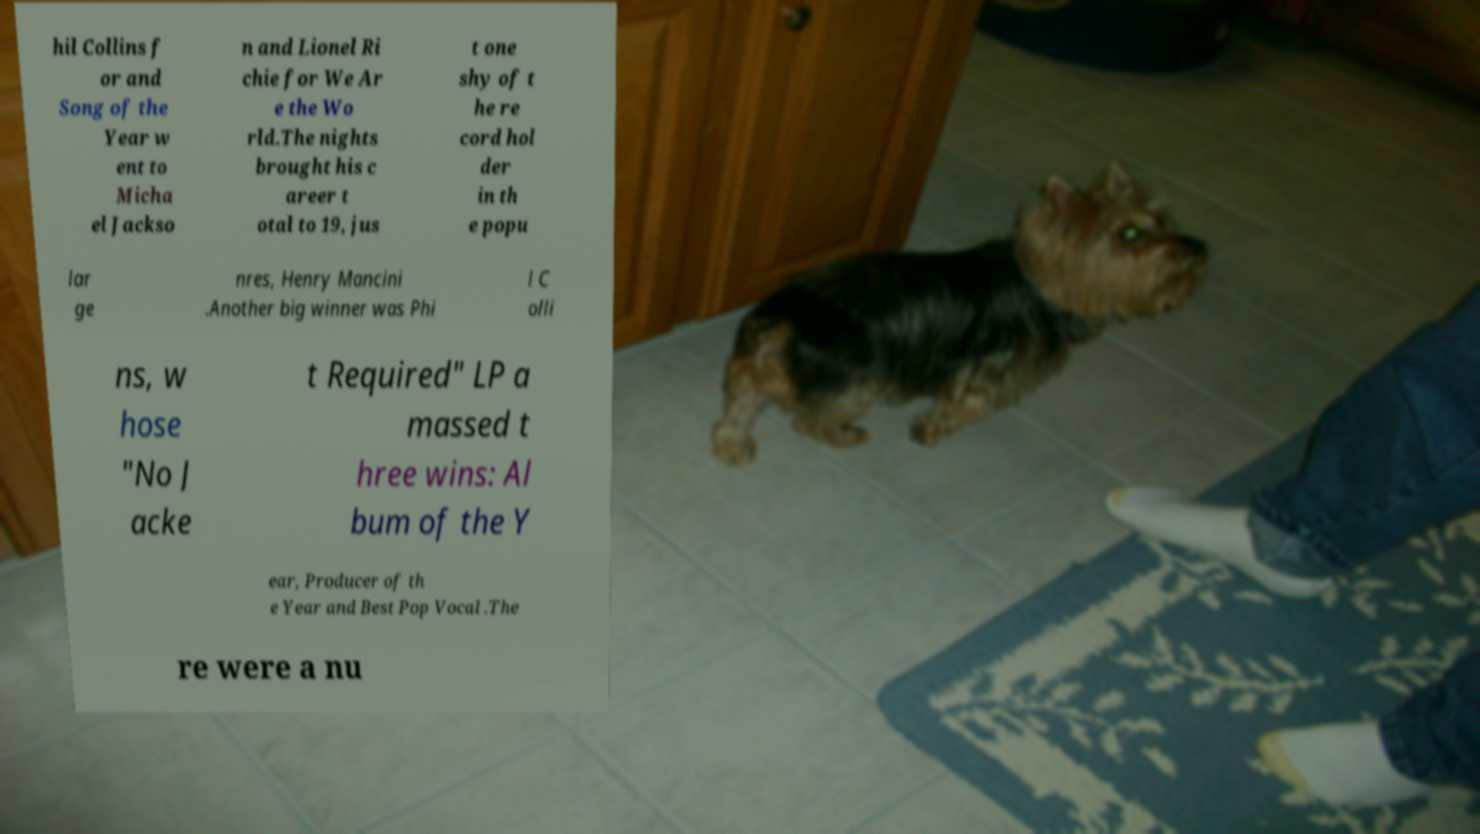Can you read and provide the text displayed in the image?This photo seems to have some interesting text. Can you extract and type it out for me? hil Collins f or and Song of the Year w ent to Micha el Jackso n and Lionel Ri chie for We Ar e the Wo rld.The nights brought his c areer t otal to 19, jus t one shy of t he re cord hol der in th e popu lar ge nres, Henry Mancini .Another big winner was Phi l C olli ns, w hose "No J acke t Required" LP a massed t hree wins: Al bum of the Y ear, Producer of th e Year and Best Pop Vocal .The re were a nu 